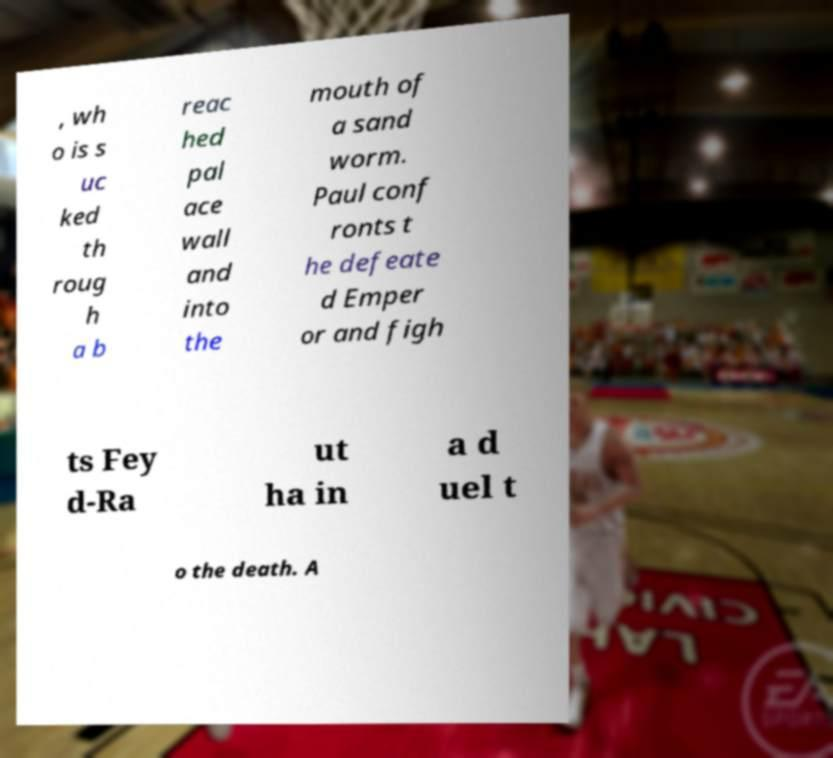I need the written content from this picture converted into text. Can you do that? , wh o is s uc ked th roug h a b reac hed pal ace wall and into the mouth of a sand worm. Paul conf ronts t he defeate d Emper or and figh ts Fey d-Ra ut ha in a d uel t o the death. A 